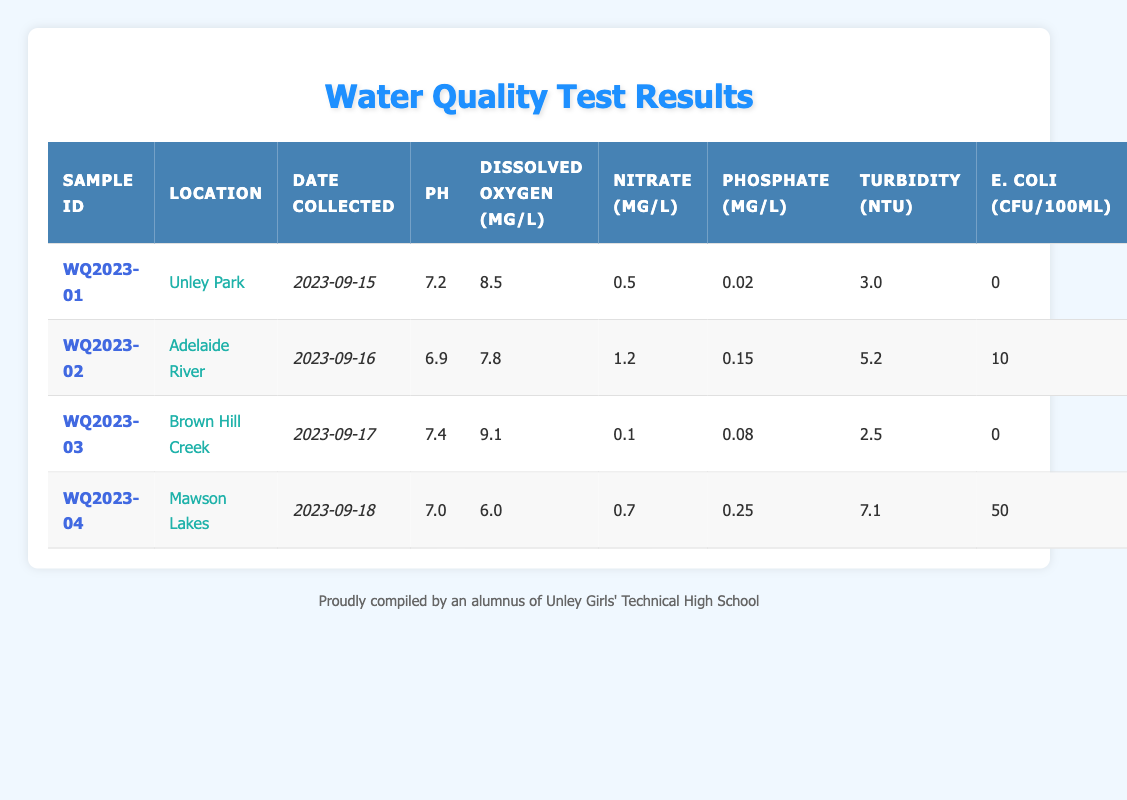What is the pH level of the water sample from Unley Park? Looking at the row for the water sample with Sample ID WQ2023-01, the pH level is listed as 7.2.
Answer: 7.2 What is the highest level of E. coli reported in the samples? In the table, the highest E. coli level is in the Mawson Lakes sample (WQ2023-04), which is reported as 50 CFU/100mL.
Answer: 50 How many water samples were collected with a turbidity level greater than 5 NTU? Looking at the turbidity values, only the Mawson Lakes sample (WQ2023-04) has a turbidity level of 7.1 NTU, which is greater than 5 NTU. Therefore, there is one sample.
Answer: 1 What is the average nitrate level across all samples? The nitrate levels are 0.5, 1.2, 0.1, and 0.7 mg/L. Summing these gives 0.5 + 1.2 + 0.1 + 0.7 = 2.5 mg/L. There are 4 samples, so the average is 2.5/4 = 0.625 mg/L.
Answer: 0.625 Is the dissolved oxygen level in Brown Hill Creek higher than in Mawson Lakes? Brown Hill Creek (WQ2023-03) reports a dissolved oxygen level of 9.1 mg/L, whereas Mawson Lakes (WQ2023-04) reports 6.0 mg/L. Since 9.1 is greater than 6.0, the statement is true.
Answer: Yes Which sample had the lowest phosphate level, and what was the value? By inspecting the phosphate levels: Unley Park has 0.02 mg/L, Adelaide River has 0.15 mg/L, Brown Hill Creek has 0.08 mg/L, and Mawson Lakes has 0.25 mg/L. Unley Park's level of 0.02 mg/L is the lowest.
Answer: Unley Park, 0.02 mg/L How does the average dissolved oxygen level compare between locations with E. coli presence and absence? The samples with E. coli are Mawson Lakes (6.0 mg/L), which has 50 CFU/100mL. The samples without E. coli are Unley Park (8.5 mg/L), and Brown Hill Creek (9.1 mg/L). The average for E. coli presence is 6.0 mg/L and for absence is (8.5 + 9.1)/2 = 8.8 mg/L. Since 6.0 is less than 8.8, the average dissolved oxygen level is higher in locations without E. coli.
Answer: Higher in absence What is the combined turbidity of the Unley Park and Brown Hill Creek samples? For Unley Park, turbidity is 3.0 NTU, and for Brown Hill Creek, it's 2.5 NTU. Adding these values gives 3.0 + 2.5 = 5.5 NTU.
Answer: 5.5 